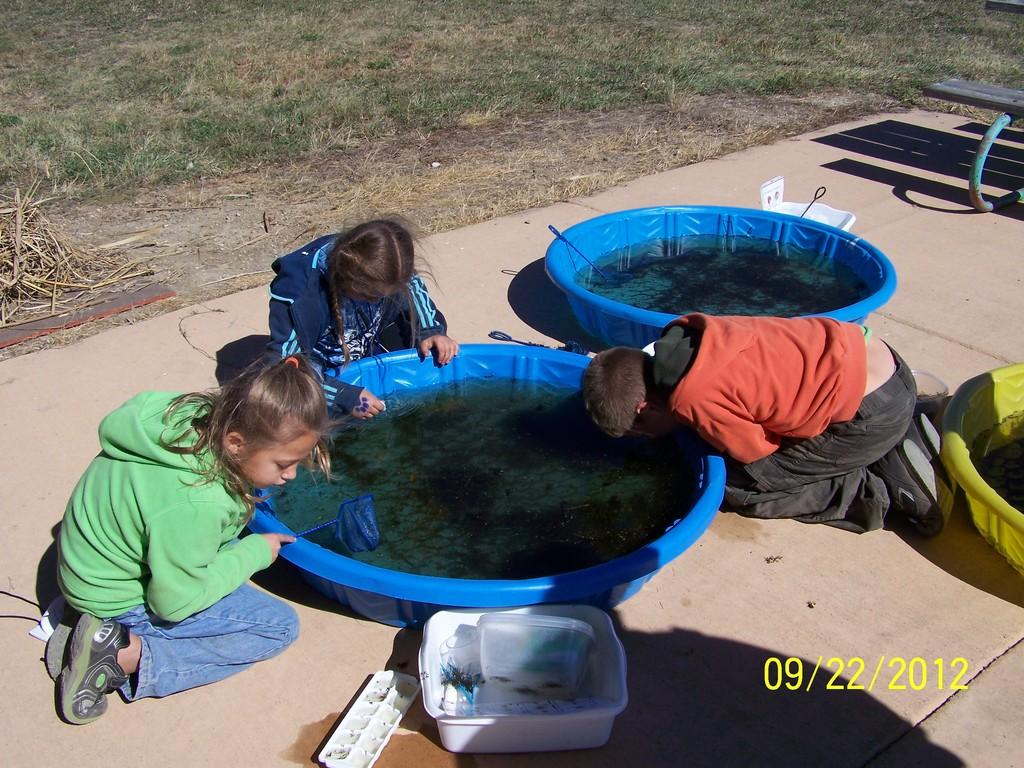How many children are in the image? There are three children in the image. What object can be seen in the image that might be used for carrying items? There is a tray in the image that could be used for carrying items. What type of objects are present in the image that might be used for storage? There are boxes in the image that could be used for storage. What objects in the image might be used for cooking or food preparation? There are spatulas in the image that could be used for cooking or food preparation. What type of containers are visible in the image? There are tubs in the image. What is the liquid visible in the image? There is water visible in the image. What type of seating is present in the image? There is a bench in the image. What feature of the bench can be seen in the image? There is a shadow of a bench in the image. What type of natural environment is visible at the top of the image? There is grass visible at the top of the image. Can you tell me how much the receipt costs in the image? There is no receipt present in the image. What memory is being triggered by the children in the image? The image does not depict any specific memory being triggered by the children. 